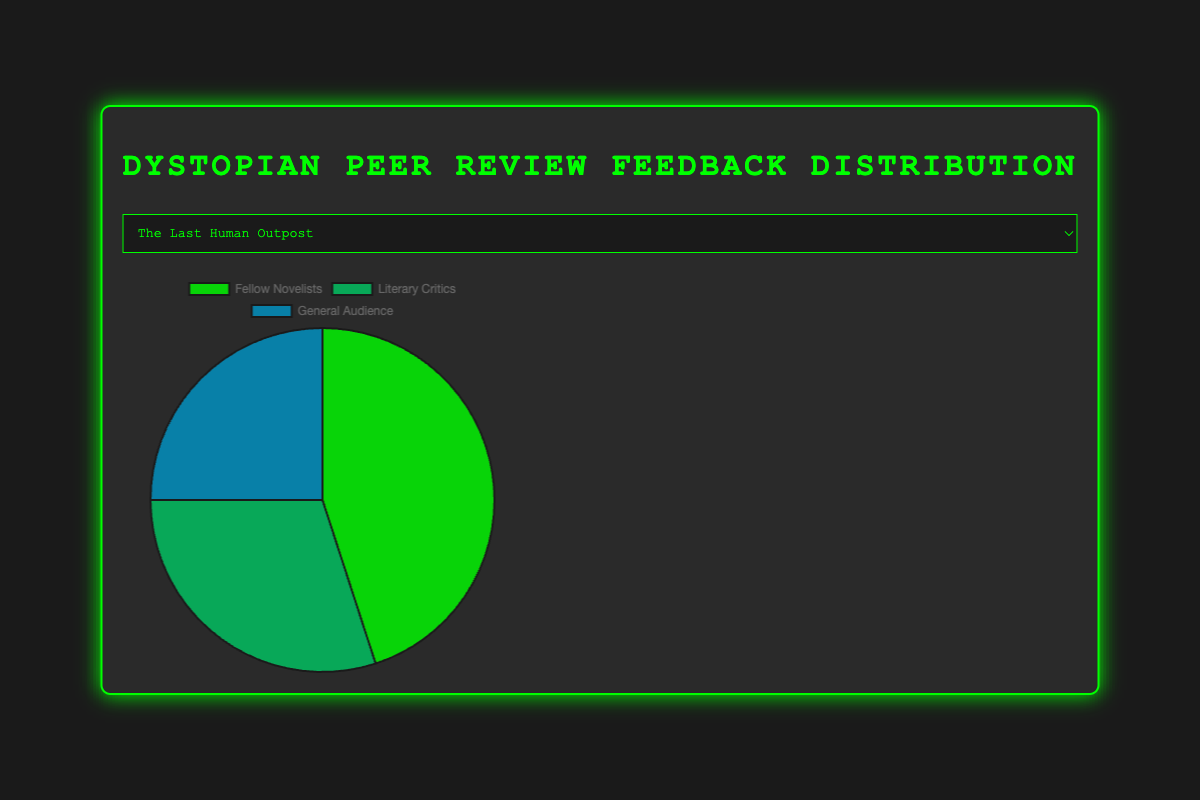Which book has the highest percentage of feedback from Fellow Novelists? To find the book with the highest percentage of feedback from Fellow Novelists, compare the values for this category across all books. "The Algorithm's End" has 60%, which is the highest.
Answer: The Algorithm's End Which book has an equal percentage of feedback from Fellow Novelists and Literary Critics? To find books with equal percentages, examine the values for each category by book. "Digital Shadows" has 40% feedback from both Fellow Novelists and Literary Critics.
Answer: Digital Shadows What is the total percentage of feedback from the General Audience for all books combined? Add the percentages of feedback from the General Audience for each book: (25 + 15 + 20 + 15 + 15) = 90.
Answer: 90% What is the average percentage of feedback from Literary Critics across all books? To get the average, sum the feedback percentages from Literary Critics for each book: (30 + 35 + 40 + 25 + 30) = 160, then divide by the number of books, which is 5. The average is 160/5 = 32.
Answer: 32% What is the difference in percentage of feedback from Fellow Novelists between "The Last Human Outpost" and "City of Drones"? Subtract the percentage for "The Last Human Outpost" from "City of Drones": 50 - 45 = 5.
Answer: 5 Which book received the lowest percentage of feedback from the General Audience? Compare the percentages of feedback from the General Audience across all books. "City of Drones," "The Algorithm's End," and "Children of the Collapse" each have the lowest at 15%.
Answer: City of Drones, The Algorithm's End, Children of the Collapse Is there any book where the feedback from Literary Critics is less than 30%? Check the Literary Critics feedback percentages for all books. "The Algorithm's End" has 25%, which is less than 30%.
Answer: The Algorithm's End If we consider the General Audience feedback for "City of Drones" and "Children of the Collapse," what is the combined percentage? Add the General Audience feedback percentages for "City of Drones" and "Children of the Collapse": 15 + 15 = 30.
Answer: 30% Which feedback source shows the most variability in percentages across all books? Calculate the range (max - min) for each feedback source: Fellow Novelists (60 - 40 = 20), Literary Critics (40 - 25 = 15), General Audience (25 - 15 = 10). "Fellow Novelists" has the most variability with a range of 20.
Answer: Fellow Novelists 